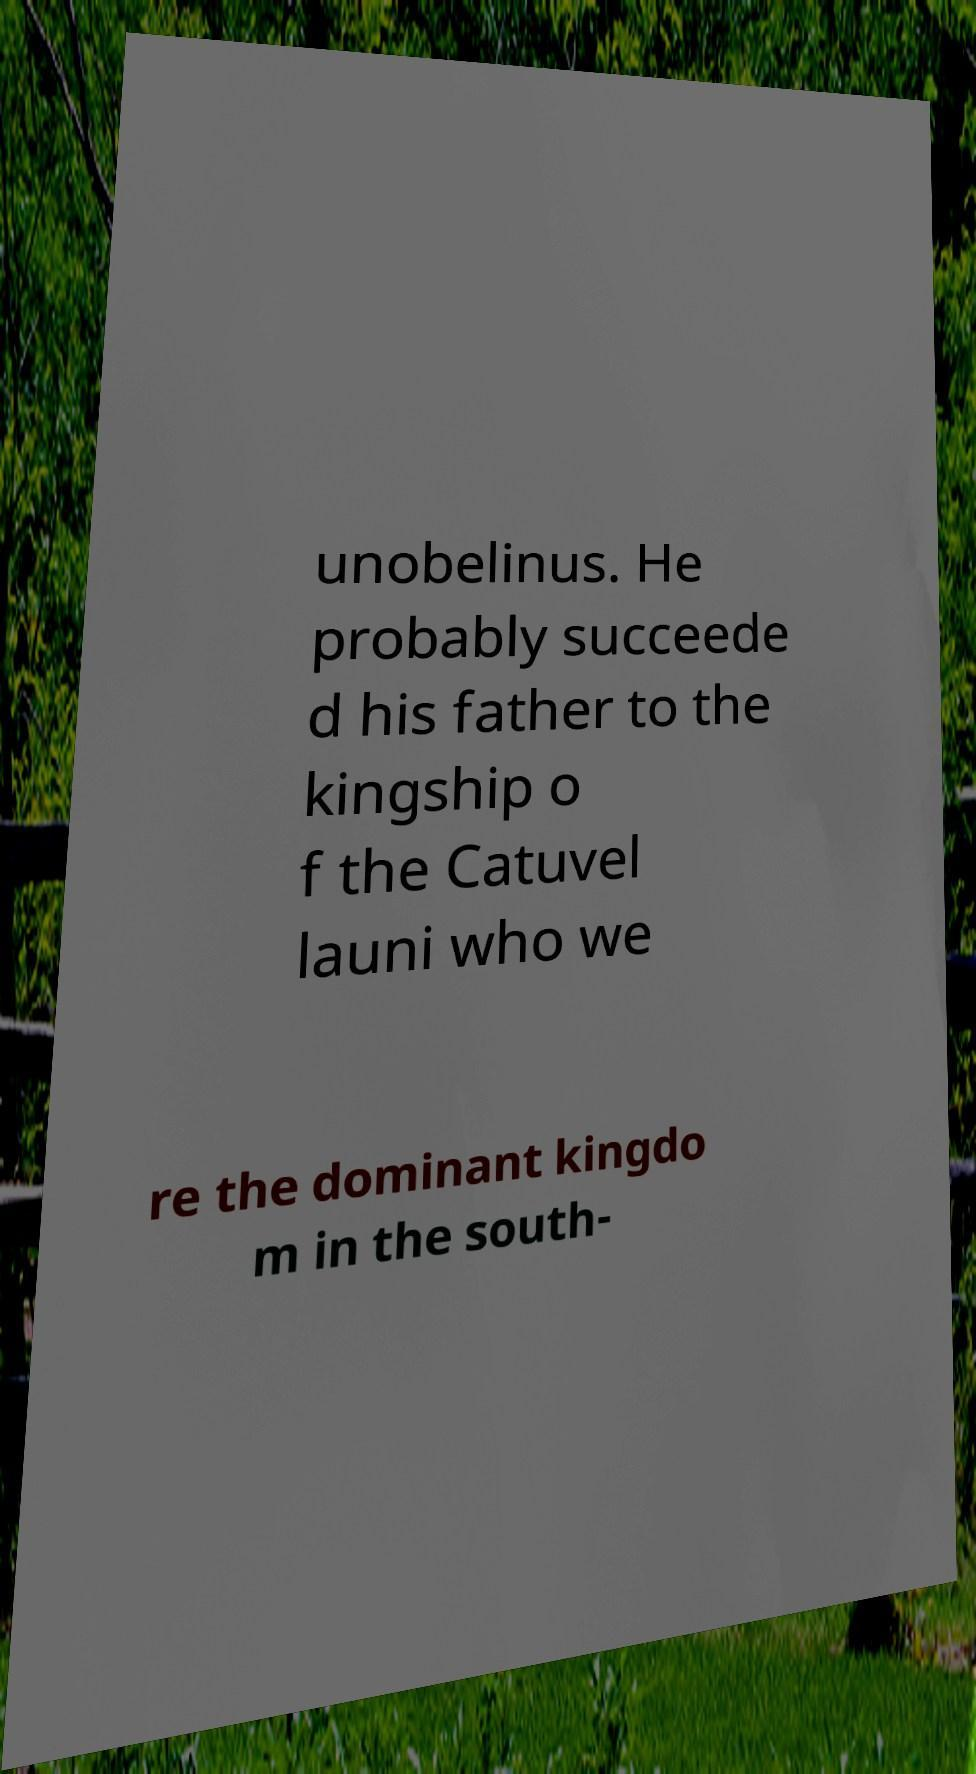Could you extract and type out the text from this image? unobelinus. He probably succeede d his father to the kingship o f the Catuvel launi who we re the dominant kingdo m in the south- 